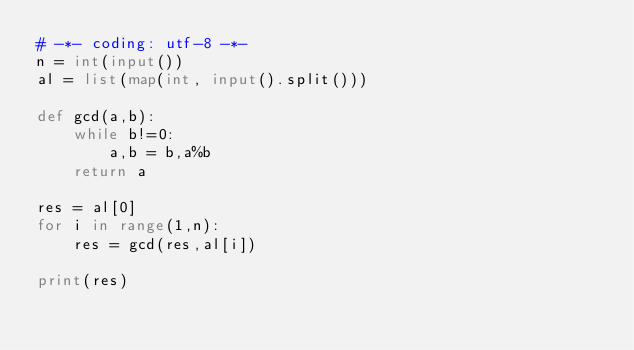<code> <loc_0><loc_0><loc_500><loc_500><_Python_># -*- coding: utf-8 -*-
n = int(input())
al = list(map(int, input().split()))

def gcd(a,b):
    while b!=0:
        a,b = b,a%b
    return a

res = al[0]
for i in range(1,n):
    res = gcd(res,al[i])

print(res)
</code> 